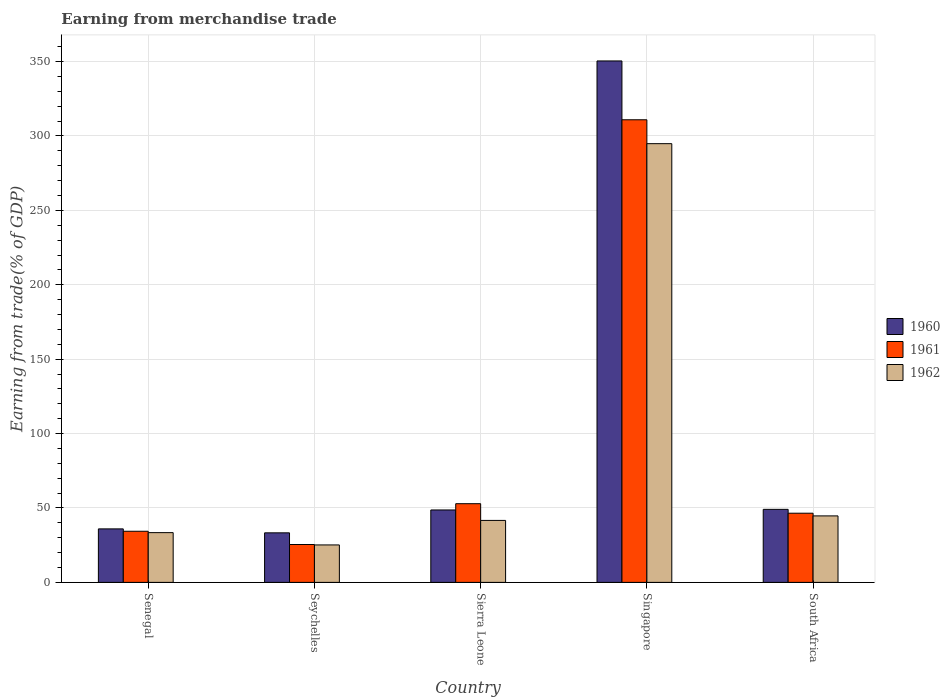How many different coloured bars are there?
Offer a terse response. 3. Are the number of bars per tick equal to the number of legend labels?
Give a very brief answer. Yes. What is the label of the 1st group of bars from the left?
Offer a terse response. Senegal. In how many cases, is the number of bars for a given country not equal to the number of legend labels?
Make the answer very short. 0. What is the earnings from trade in 1961 in Senegal?
Ensure brevity in your answer.  34.36. Across all countries, what is the maximum earnings from trade in 1962?
Give a very brief answer. 294.84. Across all countries, what is the minimum earnings from trade in 1960?
Ensure brevity in your answer.  33.3. In which country was the earnings from trade in 1961 maximum?
Ensure brevity in your answer.  Singapore. In which country was the earnings from trade in 1962 minimum?
Provide a short and direct response. Seychelles. What is the total earnings from trade in 1962 in the graph?
Offer a very short reply. 439.76. What is the difference between the earnings from trade in 1960 in Senegal and that in Sierra Leone?
Ensure brevity in your answer.  -12.72. What is the difference between the earnings from trade in 1962 in Singapore and the earnings from trade in 1961 in Senegal?
Make the answer very short. 260.48. What is the average earnings from trade in 1960 per country?
Ensure brevity in your answer.  103.49. What is the difference between the earnings from trade of/in 1960 and earnings from trade of/in 1962 in Singapore?
Your response must be concise. 55.59. What is the ratio of the earnings from trade in 1962 in Senegal to that in Sierra Leone?
Your answer should be compact. 0.8. Is the earnings from trade in 1960 in Senegal less than that in Seychelles?
Keep it short and to the point. No. Is the difference between the earnings from trade in 1960 in Seychelles and South Africa greater than the difference between the earnings from trade in 1962 in Seychelles and South Africa?
Make the answer very short. Yes. What is the difference between the highest and the second highest earnings from trade in 1962?
Give a very brief answer. -3.04. What is the difference between the highest and the lowest earnings from trade in 1960?
Give a very brief answer. 317.13. Is the sum of the earnings from trade in 1962 in Sierra Leone and South Africa greater than the maximum earnings from trade in 1961 across all countries?
Provide a succinct answer. No. What does the 1st bar from the left in Seychelles represents?
Provide a succinct answer. 1960. What does the 3rd bar from the right in Sierra Leone represents?
Ensure brevity in your answer.  1960. How many countries are there in the graph?
Your answer should be very brief. 5. What is the difference between two consecutive major ticks on the Y-axis?
Offer a terse response. 50. Does the graph contain grids?
Offer a very short reply. Yes. How are the legend labels stacked?
Give a very brief answer. Vertical. What is the title of the graph?
Give a very brief answer. Earning from merchandise trade. Does "1966" appear as one of the legend labels in the graph?
Your answer should be very brief. No. What is the label or title of the Y-axis?
Give a very brief answer. Earning from trade(% of GDP). What is the Earning from trade(% of GDP) of 1960 in Senegal?
Offer a very short reply. 35.95. What is the Earning from trade(% of GDP) of 1961 in Senegal?
Ensure brevity in your answer.  34.36. What is the Earning from trade(% of GDP) of 1962 in Senegal?
Ensure brevity in your answer.  33.43. What is the Earning from trade(% of GDP) in 1960 in Seychelles?
Offer a very short reply. 33.3. What is the Earning from trade(% of GDP) of 1961 in Seychelles?
Make the answer very short. 25.45. What is the Earning from trade(% of GDP) in 1962 in Seychelles?
Provide a short and direct response. 25.17. What is the Earning from trade(% of GDP) of 1960 in Sierra Leone?
Your response must be concise. 48.67. What is the Earning from trade(% of GDP) in 1961 in Sierra Leone?
Keep it short and to the point. 52.88. What is the Earning from trade(% of GDP) of 1962 in Sierra Leone?
Provide a succinct answer. 41.64. What is the Earning from trade(% of GDP) of 1960 in Singapore?
Your answer should be compact. 350.43. What is the Earning from trade(% of GDP) of 1961 in Singapore?
Your response must be concise. 310.9. What is the Earning from trade(% of GDP) in 1962 in Singapore?
Provide a short and direct response. 294.84. What is the Earning from trade(% of GDP) of 1960 in South Africa?
Your answer should be very brief. 49.08. What is the Earning from trade(% of GDP) of 1961 in South Africa?
Your response must be concise. 46.49. What is the Earning from trade(% of GDP) of 1962 in South Africa?
Offer a terse response. 44.68. Across all countries, what is the maximum Earning from trade(% of GDP) of 1960?
Make the answer very short. 350.43. Across all countries, what is the maximum Earning from trade(% of GDP) of 1961?
Provide a succinct answer. 310.9. Across all countries, what is the maximum Earning from trade(% of GDP) of 1962?
Your response must be concise. 294.84. Across all countries, what is the minimum Earning from trade(% of GDP) of 1960?
Offer a terse response. 33.3. Across all countries, what is the minimum Earning from trade(% of GDP) in 1961?
Your answer should be compact. 25.45. Across all countries, what is the minimum Earning from trade(% of GDP) in 1962?
Provide a short and direct response. 25.17. What is the total Earning from trade(% of GDP) in 1960 in the graph?
Your answer should be compact. 517.43. What is the total Earning from trade(% of GDP) of 1961 in the graph?
Give a very brief answer. 470.07. What is the total Earning from trade(% of GDP) in 1962 in the graph?
Ensure brevity in your answer.  439.76. What is the difference between the Earning from trade(% of GDP) in 1960 in Senegal and that in Seychelles?
Your answer should be compact. 2.65. What is the difference between the Earning from trade(% of GDP) in 1961 in Senegal and that in Seychelles?
Your answer should be very brief. 8.9. What is the difference between the Earning from trade(% of GDP) of 1962 in Senegal and that in Seychelles?
Keep it short and to the point. 8.27. What is the difference between the Earning from trade(% of GDP) in 1960 in Senegal and that in Sierra Leone?
Offer a terse response. -12.72. What is the difference between the Earning from trade(% of GDP) of 1961 in Senegal and that in Sierra Leone?
Your answer should be very brief. -18.53. What is the difference between the Earning from trade(% of GDP) of 1962 in Senegal and that in Sierra Leone?
Offer a terse response. -8.21. What is the difference between the Earning from trade(% of GDP) of 1960 in Senegal and that in Singapore?
Keep it short and to the point. -314.48. What is the difference between the Earning from trade(% of GDP) in 1961 in Senegal and that in Singapore?
Make the answer very short. -276.54. What is the difference between the Earning from trade(% of GDP) in 1962 in Senegal and that in Singapore?
Ensure brevity in your answer.  -261.41. What is the difference between the Earning from trade(% of GDP) in 1960 in Senegal and that in South Africa?
Provide a short and direct response. -13.13. What is the difference between the Earning from trade(% of GDP) of 1961 in Senegal and that in South Africa?
Offer a terse response. -12.13. What is the difference between the Earning from trade(% of GDP) in 1962 in Senegal and that in South Africa?
Provide a short and direct response. -11.25. What is the difference between the Earning from trade(% of GDP) of 1960 in Seychelles and that in Sierra Leone?
Ensure brevity in your answer.  -15.37. What is the difference between the Earning from trade(% of GDP) of 1961 in Seychelles and that in Sierra Leone?
Offer a very short reply. -27.43. What is the difference between the Earning from trade(% of GDP) in 1962 in Seychelles and that in Sierra Leone?
Your response must be concise. -16.48. What is the difference between the Earning from trade(% of GDP) of 1960 in Seychelles and that in Singapore?
Ensure brevity in your answer.  -317.13. What is the difference between the Earning from trade(% of GDP) of 1961 in Seychelles and that in Singapore?
Give a very brief answer. -285.44. What is the difference between the Earning from trade(% of GDP) in 1962 in Seychelles and that in Singapore?
Keep it short and to the point. -269.67. What is the difference between the Earning from trade(% of GDP) in 1960 in Seychelles and that in South Africa?
Give a very brief answer. -15.78. What is the difference between the Earning from trade(% of GDP) of 1961 in Seychelles and that in South Africa?
Provide a short and direct response. -21.03. What is the difference between the Earning from trade(% of GDP) in 1962 in Seychelles and that in South Africa?
Ensure brevity in your answer.  -19.51. What is the difference between the Earning from trade(% of GDP) in 1960 in Sierra Leone and that in Singapore?
Provide a succinct answer. -301.76. What is the difference between the Earning from trade(% of GDP) in 1961 in Sierra Leone and that in Singapore?
Your answer should be very brief. -258.02. What is the difference between the Earning from trade(% of GDP) in 1962 in Sierra Leone and that in Singapore?
Your answer should be compact. -253.19. What is the difference between the Earning from trade(% of GDP) of 1960 in Sierra Leone and that in South Africa?
Offer a terse response. -0.41. What is the difference between the Earning from trade(% of GDP) of 1961 in Sierra Leone and that in South Africa?
Provide a short and direct response. 6.4. What is the difference between the Earning from trade(% of GDP) in 1962 in Sierra Leone and that in South Africa?
Give a very brief answer. -3.04. What is the difference between the Earning from trade(% of GDP) of 1960 in Singapore and that in South Africa?
Your response must be concise. 301.35. What is the difference between the Earning from trade(% of GDP) of 1961 in Singapore and that in South Africa?
Make the answer very short. 264.41. What is the difference between the Earning from trade(% of GDP) in 1962 in Singapore and that in South Africa?
Offer a very short reply. 250.16. What is the difference between the Earning from trade(% of GDP) in 1960 in Senegal and the Earning from trade(% of GDP) in 1961 in Seychelles?
Keep it short and to the point. 10.5. What is the difference between the Earning from trade(% of GDP) in 1960 in Senegal and the Earning from trade(% of GDP) in 1962 in Seychelles?
Make the answer very short. 10.78. What is the difference between the Earning from trade(% of GDP) of 1961 in Senegal and the Earning from trade(% of GDP) of 1962 in Seychelles?
Your response must be concise. 9.19. What is the difference between the Earning from trade(% of GDP) of 1960 in Senegal and the Earning from trade(% of GDP) of 1961 in Sierra Leone?
Provide a short and direct response. -16.93. What is the difference between the Earning from trade(% of GDP) of 1960 in Senegal and the Earning from trade(% of GDP) of 1962 in Sierra Leone?
Give a very brief answer. -5.69. What is the difference between the Earning from trade(% of GDP) of 1961 in Senegal and the Earning from trade(% of GDP) of 1962 in Sierra Leone?
Provide a succinct answer. -7.29. What is the difference between the Earning from trade(% of GDP) of 1960 in Senegal and the Earning from trade(% of GDP) of 1961 in Singapore?
Make the answer very short. -274.95. What is the difference between the Earning from trade(% of GDP) in 1960 in Senegal and the Earning from trade(% of GDP) in 1962 in Singapore?
Offer a very short reply. -258.89. What is the difference between the Earning from trade(% of GDP) of 1961 in Senegal and the Earning from trade(% of GDP) of 1962 in Singapore?
Your answer should be compact. -260.48. What is the difference between the Earning from trade(% of GDP) in 1960 in Senegal and the Earning from trade(% of GDP) in 1961 in South Africa?
Make the answer very short. -10.53. What is the difference between the Earning from trade(% of GDP) in 1960 in Senegal and the Earning from trade(% of GDP) in 1962 in South Africa?
Ensure brevity in your answer.  -8.73. What is the difference between the Earning from trade(% of GDP) of 1961 in Senegal and the Earning from trade(% of GDP) of 1962 in South Africa?
Your answer should be compact. -10.33. What is the difference between the Earning from trade(% of GDP) in 1960 in Seychelles and the Earning from trade(% of GDP) in 1961 in Sierra Leone?
Your answer should be very brief. -19.58. What is the difference between the Earning from trade(% of GDP) of 1960 in Seychelles and the Earning from trade(% of GDP) of 1962 in Sierra Leone?
Offer a very short reply. -8.34. What is the difference between the Earning from trade(% of GDP) in 1961 in Seychelles and the Earning from trade(% of GDP) in 1962 in Sierra Leone?
Offer a very short reply. -16.19. What is the difference between the Earning from trade(% of GDP) in 1960 in Seychelles and the Earning from trade(% of GDP) in 1961 in Singapore?
Your response must be concise. -277.6. What is the difference between the Earning from trade(% of GDP) of 1960 in Seychelles and the Earning from trade(% of GDP) of 1962 in Singapore?
Offer a terse response. -261.54. What is the difference between the Earning from trade(% of GDP) in 1961 in Seychelles and the Earning from trade(% of GDP) in 1962 in Singapore?
Ensure brevity in your answer.  -269.38. What is the difference between the Earning from trade(% of GDP) of 1960 in Seychelles and the Earning from trade(% of GDP) of 1961 in South Africa?
Keep it short and to the point. -13.19. What is the difference between the Earning from trade(% of GDP) of 1960 in Seychelles and the Earning from trade(% of GDP) of 1962 in South Africa?
Offer a terse response. -11.38. What is the difference between the Earning from trade(% of GDP) in 1961 in Seychelles and the Earning from trade(% of GDP) in 1962 in South Africa?
Provide a succinct answer. -19.23. What is the difference between the Earning from trade(% of GDP) in 1960 in Sierra Leone and the Earning from trade(% of GDP) in 1961 in Singapore?
Your response must be concise. -262.23. What is the difference between the Earning from trade(% of GDP) in 1960 in Sierra Leone and the Earning from trade(% of GDP) in 1962 in Singapore?
Provide a succinct answer. -246.17. What is the difference between the Earning from trade(% of GDP) of 1961 in Sierra Leone and the Earning from trade(% of GDP) of 1962 in Singapore?
Make the answer very short. -241.96. What is the difference between the Earning from trade(% of GDP) in 1960 in Sierra Leone and the Earning from trade(% of GDP) in 1961 in South Africa?
Provide a short and direct response. 2.18. What is the difference between the Earning from trade(% of GDP) of 1960 in Sierra Leone and the Earning from trade(% of GDP) of 1962 in South Africa?
Provide a succinct answer. 3.99. What is the difference between the Earning from trade(% of GDP) of 1961 in Sierra Leone and the Earning from trade(% of GDP) of 1962 in South Africa?
Your response must be concise. 8.2. What is the difference between the Earning from trade(% of GDP) of 1960 in Singapore and the Earning from trade(% of GDP) of 1961 in South Africa?
Make the answer very short. 303.95. What is the difference between the Earning from trade(% of GDP) in 1960 in Singapore and the Earning from trade(% of GDP) in 1962 in South Africa?
Your answer should be compact. 305.75. What is the difference between the Earning from trade(% of GDP) in 1961 in Singapore and the Earning from trade(% of GDP) in 1962 in South Africa?
Your answer should be very brief. 266.22. What is the average Earning from trade(% of GDP) in 1960 per country?
Give a very brief answer. 103.49. What is the average Earning from trade(% of GDP) of 1961 per country?
Your answer should be very brief. 94.01. What is the average Earning from trade(% of GDP) in 1962 per country?
Give a very brief answer. 87.95. What is the difference between the Earning from trade(% of GDP) in 1960 and Earning from trade(% of GDP) in 1961 in Senegal?
Offer a very short reply. 1.6. What is the difference between the Earning from trade(% of GDP) in 1960 and Earning from trade(% of GDP) in 1962 in Senegal?
Your answer should be compact. 2.52. What is the difference between the Earning from trade(% of GDP) of 1961 and Earning from trade(% of GDP) of 1962 in Senegal?
Make the answer very short. 0.92. What is the difference between the Earning from trade(% of GDP) of 1960 and Earning from trade(% of GDP) of 1961 in Seychelles?
Offer a terse response. 7.85. What is the difference between the Earning from trade(% of GDP) in 1960 and Earning from trade(% of GDP) in 1962 in Seychelles?
Provide a succinct answer. 8.13. What is the difference between the Earning from trade(% of GDP) of 1961 and Earning from trade(% of GDP) of 1962 in Seychelles?
Make the answer very short. 0.29. What is the difference between the Earning from trade(% of GDP) of 1960 and Earning from trade(% of GDP) of 1961 in Sierra Leone?
Provide a succinct answer. -4.21. What is the difference between the Earning from trade(% of GDP) in 1960 and Earning from trade(% of GDP) in 1962 in Sierra Leone?
Ensure brevity in your answer.  7.03. What is the difference between the Earning from trade(% of GDP) in 1961 and Earning from trade(% of GDP) in 1962 in Sierra Leone?
Offer a very short reply. 11.24. What is the difference between the Earning from trade(% of GDP) in 1960 and Earning from trade(% of GDP) in 1961 in Singapore?
Give a very brief answer. 39.53. What is the difference between the Earning from trade(% of GDP) of 1960 and Earning from trade(% of GDP) of 1962 in Singapore?
Provide a short and direct response. 55.59. What is the difference between the Earning from trade(% of GDP) of 1961 and Earning from trade(% of GDP) of 1962 in Singapore?
Provide a succinct answer. 16.06. What is the difference between the Earning from trade(% of GDP) of 1960 and Earning from trade(% of GDP) of 1961 in South Africa?
Provide a succinct answer. 2.59. What is the difference between the Earning from trade(% of GDP) of 1960 and Earning from trade(% of GDP) of 1962 in South Africa?
Give a very brief answer. 4.4. What is the difference between the Earning from trade(% of GDP) of 1961 and Earning from trade(% of GDP) of 1962 in South Africa?
Give a very brief answer. 1.8. What is the ratio of the Earning from trade(% of GDP) in 1960 in Senegal to that in Seychelles?
Provide a short and direct response. 1.08. What is the ratio of the Earning from trade(% of GDP) of 1961 in Senegal to that in Seychelles?
Offer a terse response. 1.35. What is the ratio of the Earning from trade(% of GDP) of 1962 in Senegal to that in Seychelles?
Make the answer very short. 1.33. What is the ratio of the Earning from trade(% of GDP) in 1960 in Senegal to that in Sierra Leone?
Give a very brief answer. 0.74. What is the ratio of the Earning from trade(% of GDP) of 1961 in Senegal to that in Sierra Leone?
Your answer should be compact. 0.65. What is the ratio of the Earning from trade(% of GDP) of 1962 in Senegal to that in Sierra Leone?
Keep it short and to the point. 0.8. What is the ratio of the Earning from trade(% of GDP) of 1960 in Senegal to that in Singapore?
Provide a succinct answer. 0.1. What is the ratio of the Earning from trade(% of GDP) of 1961 in Senegal to that in Singapore?
Give a very brief answer. 0.11. What is the ratio of the Earning from trade(% of GDP) in 1962 in Senegal to that in Singapore?
Your response must be concise. 0.11. What is the ratio of the Earning from trade(% of GDP) of 1960 in Senegal to that in South Africa?
Offer a very short reply. 0.73. What is the ratio of the Earning from trade(% of GDP) in 1961 in Senegal to that in South Africa?
Your response must be concise. 0.74. What is the ratio of the Earning from trade(% of GDP) of 1962 in Senegal to that in South Africa?
Provide a succinct answer. 0.75. What is the ratio of the Earning from trade(% of GDP) in 1960 in Seychelles to that in Sierra Leone?
Offer a very short reply. 0.68. What is the ratio of the Earning from trade(% of GDP) of 1961 in Seychelles to that in Sierra Leone?
Offer a terse response. 0.48. What is the ratio of the Earning from trade(% of GDP) in 1962 in Seychelles to that in Sierra Leone?
Your response must be concise. 0.6. What is the ratio of the Earning from trade(% of GDP) of 1960 in Seychelles to that in Singapore?
Give a very brief answer. 0.1. What is the ratio of the Earning from trade(% of GDP) in 1961 in Seychelles to that in Singapore?
Keep it short and to the point. 0.08. What is the ratio of the Earning from trade(% of GDP) in 1962 in Seychelles to that in Singapore?
Your answer should be compact. 0.09. What is the ratio of the Earning from trade(% of GDP) in 1960 in Seychelles to that in South Africa?
Your response must be concise. 0.68. What is the ratio of the Earning from trade(% of GDP) of 1961 in Seychelles to that in South Africa?
Make the answer very short. 0.55. What is the ratio of the Earning from trade(% of GDP) in 1962 in Seychelles to that in South Africa?
Offer a terse response. 0.56. What is the ratio of the Earning from trade(% of GDP) of 1960 in Sierra Leone to that in Singapore?
Make the answer very short. 0.14. What is the ratio of the Earning from trade(% of GDP) of 1961 in Sierra Leone to that in Singapore?
Provide a short and direct response. 0.17. What is the ratio of the Earning from trade(% of GDP) in 1962 in Sierra Leone to that in Singapore?
Offer a terse response. 0.14. What is the ratio of the Earning from trade(% of GDP) of 1961 in Sierra Leone to that in South Africa?
Provide a short and direct response. 1.14. What is the ratio of the Earning from trade(% of GDP) of 1962 in Sierra Leone to that in South Africa?
Your answer should be compact. 0.93. What is the ratio of the Earning from trade(% of GDP) in 1960 in Singapore to that in South Africa?
Your answer should be very brief. 7.14. What is the ratio of the Earning from trade(% of GDP) in 1961 in Singapore to that in South Africa?
Provide a succinct answer. 6.69. What is the ratio of the Earning from trade(% of GDP) in 1962 in Singapore to that in South Africa?
Offer a terse response. 6.6. What is the difference between the highest and the second highest Earning from trade(% of GDP) in 1960?
Your answer should be very brief. 301.35. What is the difference between the highest and the second highest Earning from trade(% of GDP) in 1961?
Ensure brevity in your answer.  258.02. What is the difference between the highest and the second highest Earning from trade(% of GDP) in 1962?
Your answer should be compact. 250.16. What is the difference between the highest and the lowest Earning from trade(% of GDP) of 1960?
Your answer should be very brief. 317.13. What is the difference between the highest and the lowest Earning from trade(% of GDP) of 1961?
Keep it short and to the point. 285.44. What is the difference between the highest and the lowest Earning from trade(% of GDP) of 1962?
Give a very brief answer. 269.67. 